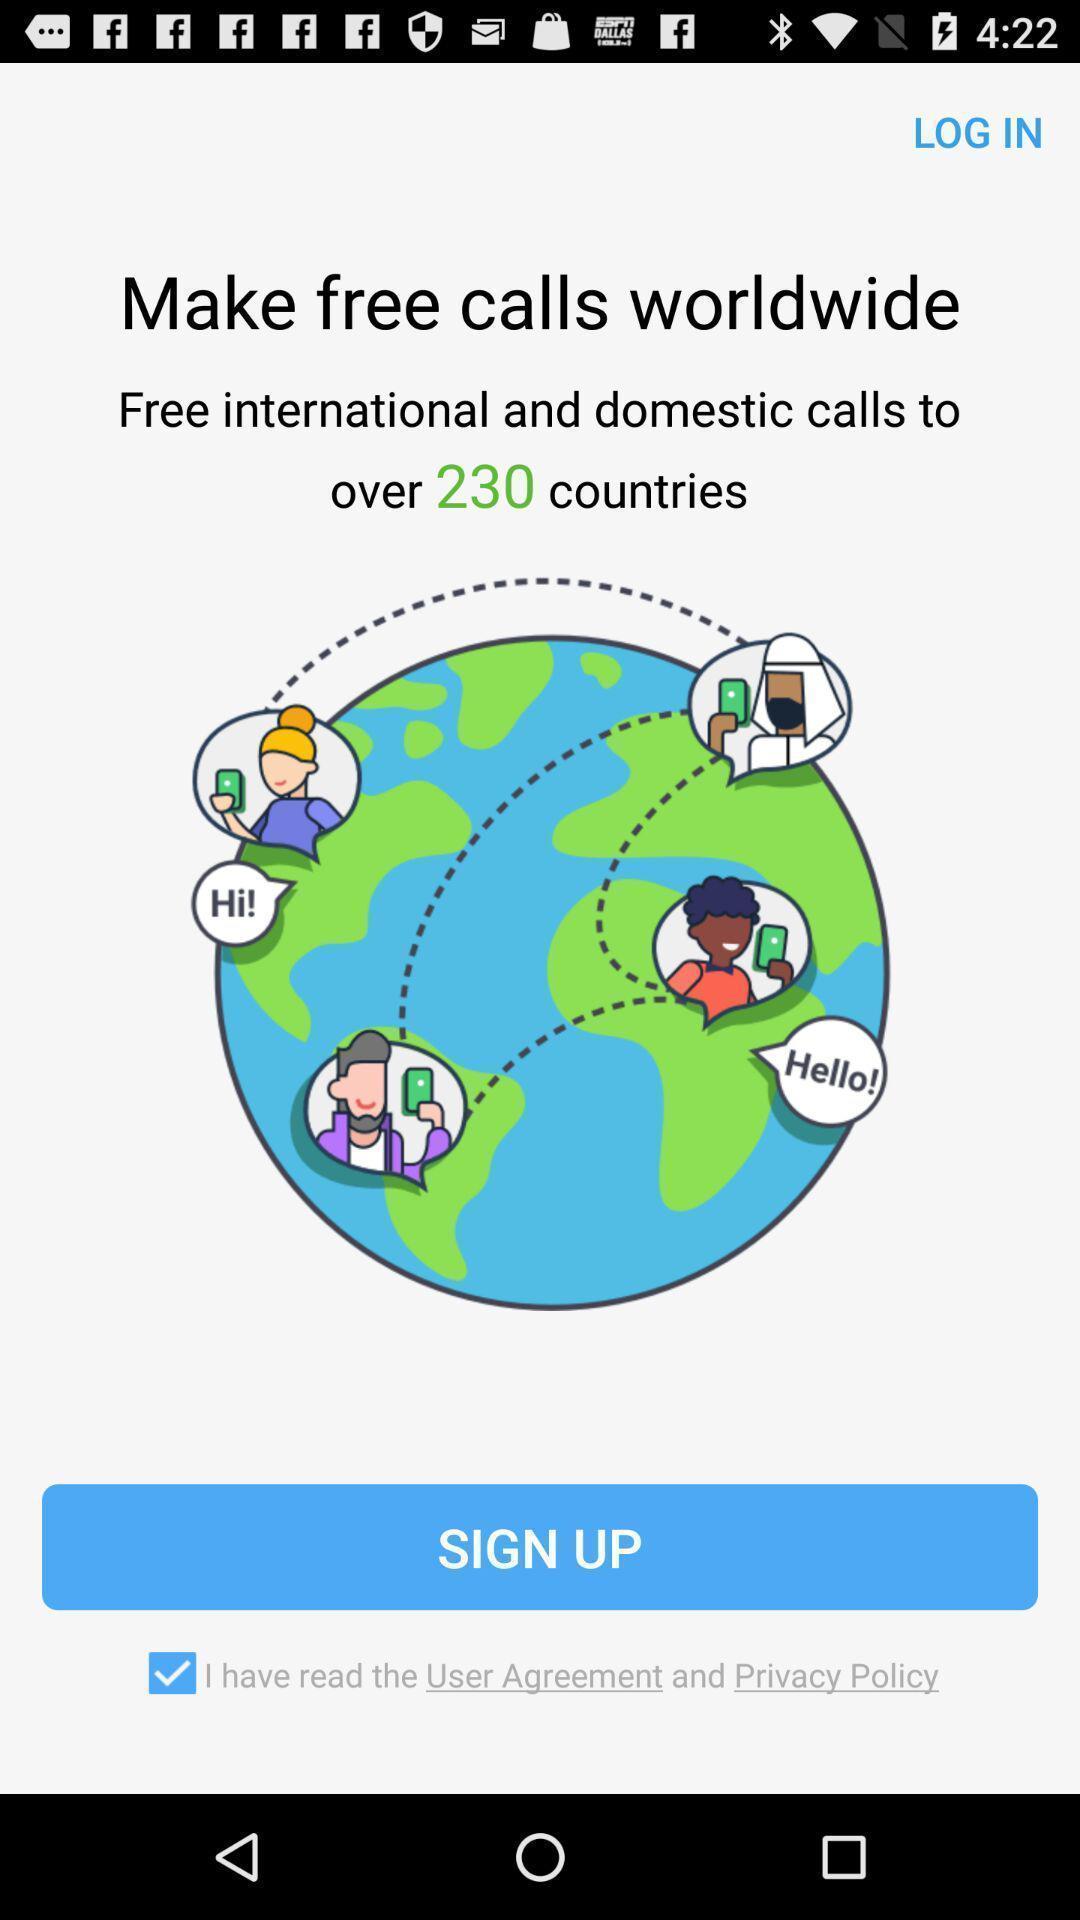Tell me what you see in this picture. Welcome page. 